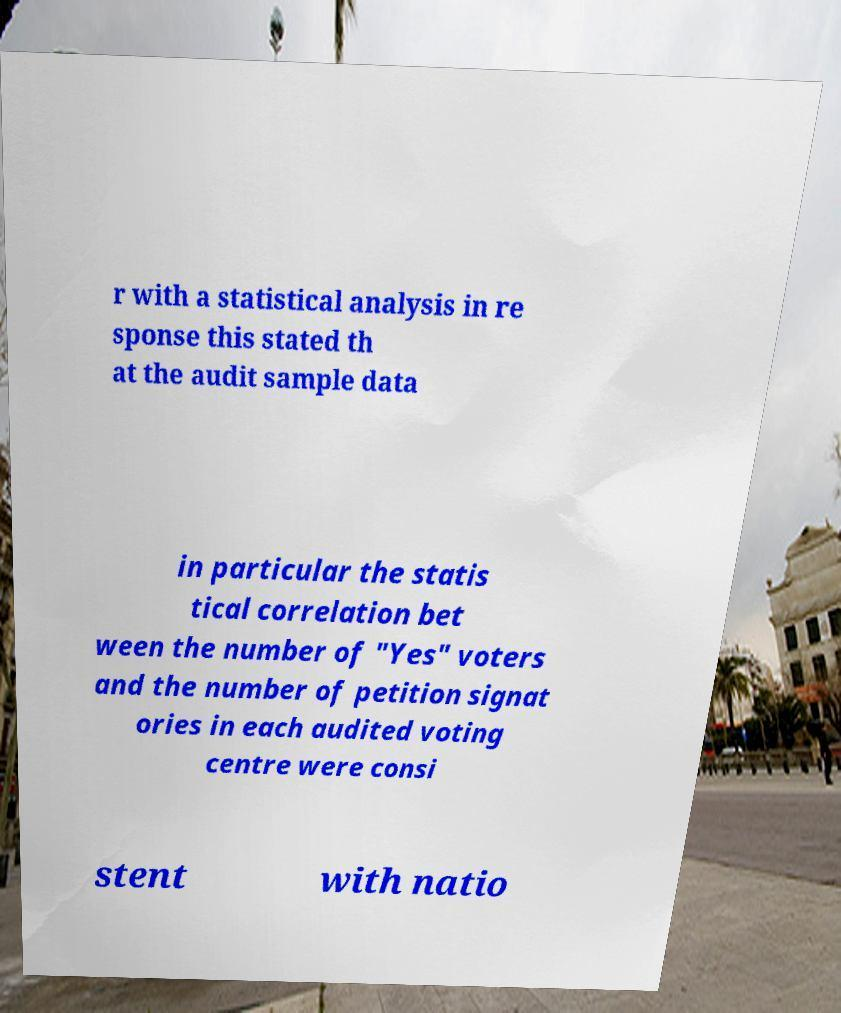Could you extract and type out the text from this image? r with a statistical analysis in re sponse this stated th at the audit sample data in particular the statis tical correlation bet ween the number of "Yes" voters and the number of petition signat ories in each audited voting centre were consi stent with natio 